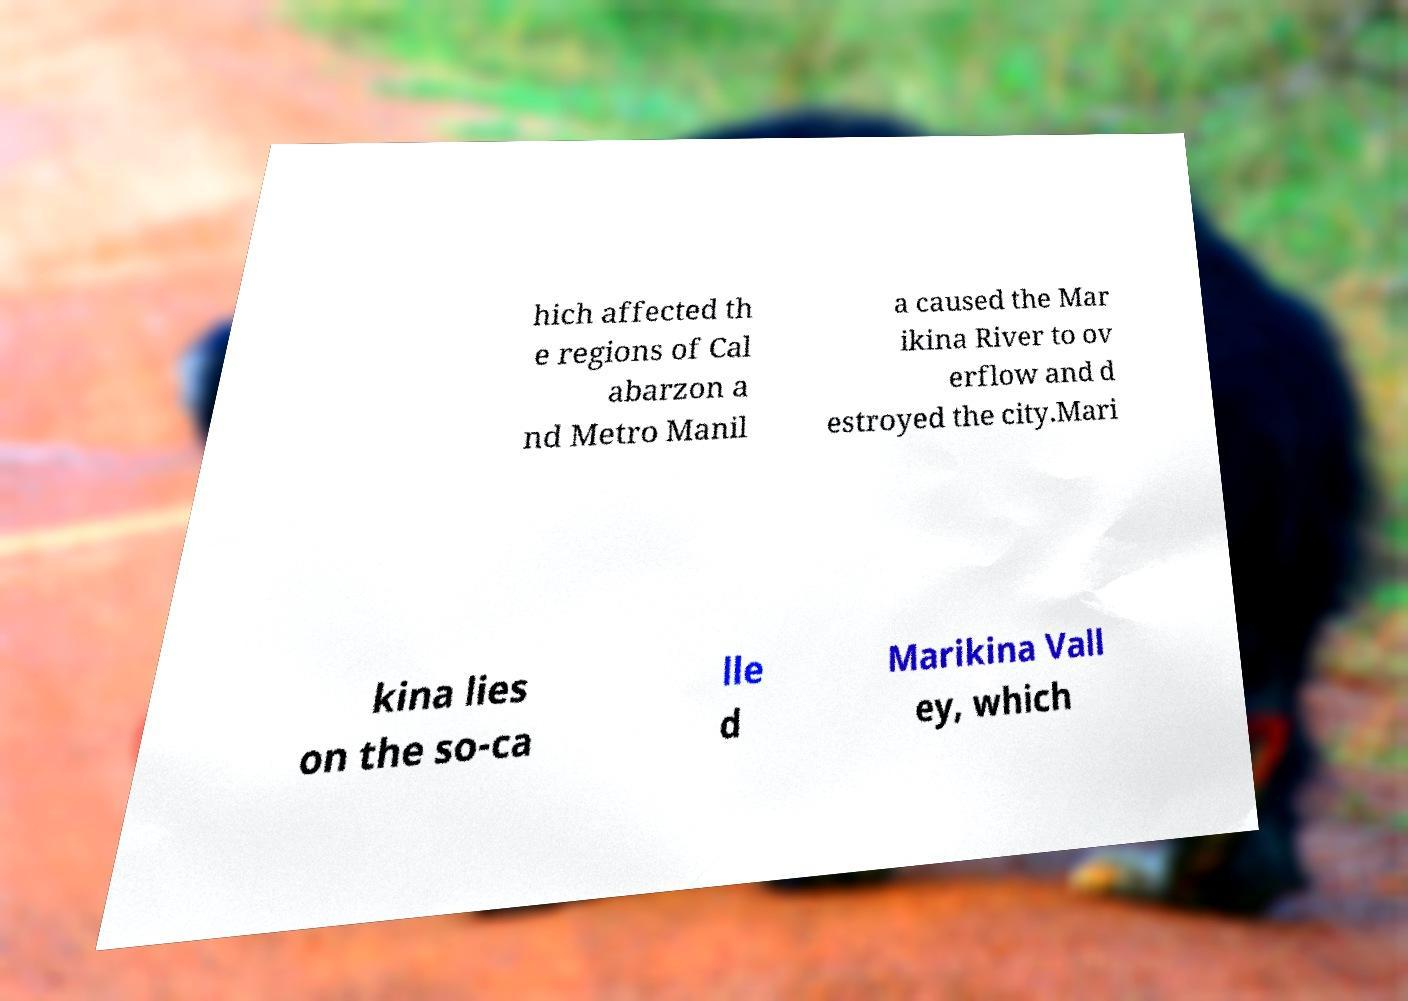There's text embedded in this image that I need extracted. Can you transcribe it verbatim? hich affected th e regions of Cal abarzon a nd Metro Manil a caused the Mar ikina River to ov erflow and d estroyed the city.Mari kina lies on the so-ca lle d Marikina Vall ey, which 